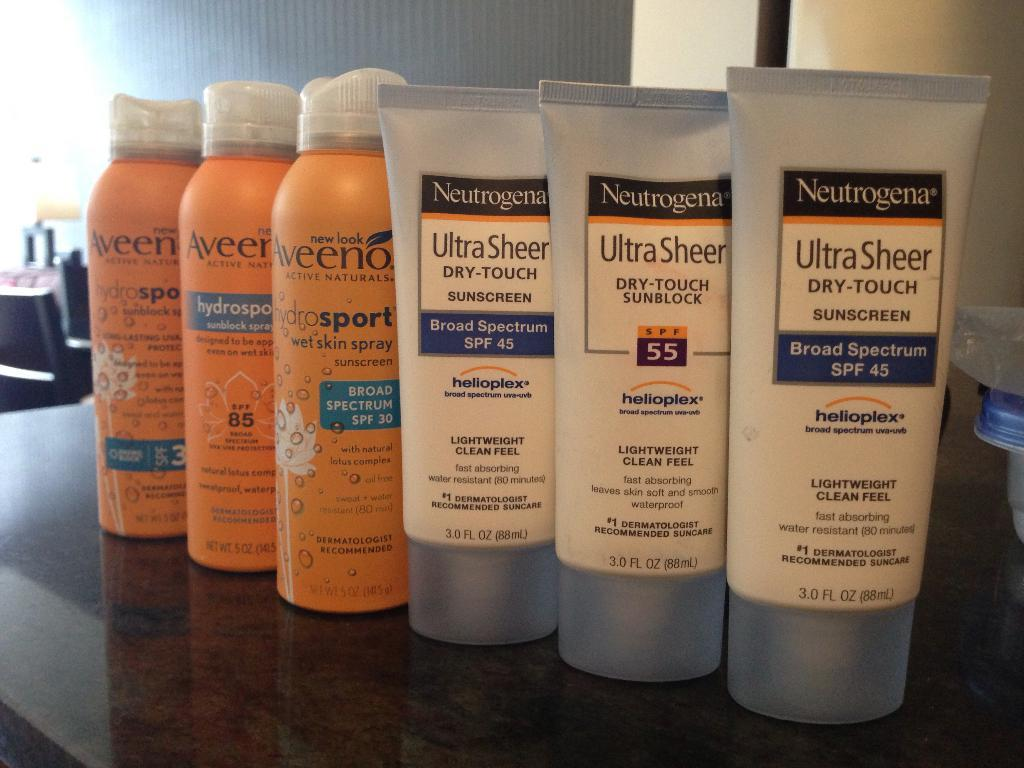<image>
Describe the image concisely. 3 orange bottle of aveeno products and 3 tubes of neutrogena ultra sheer sunscreen 